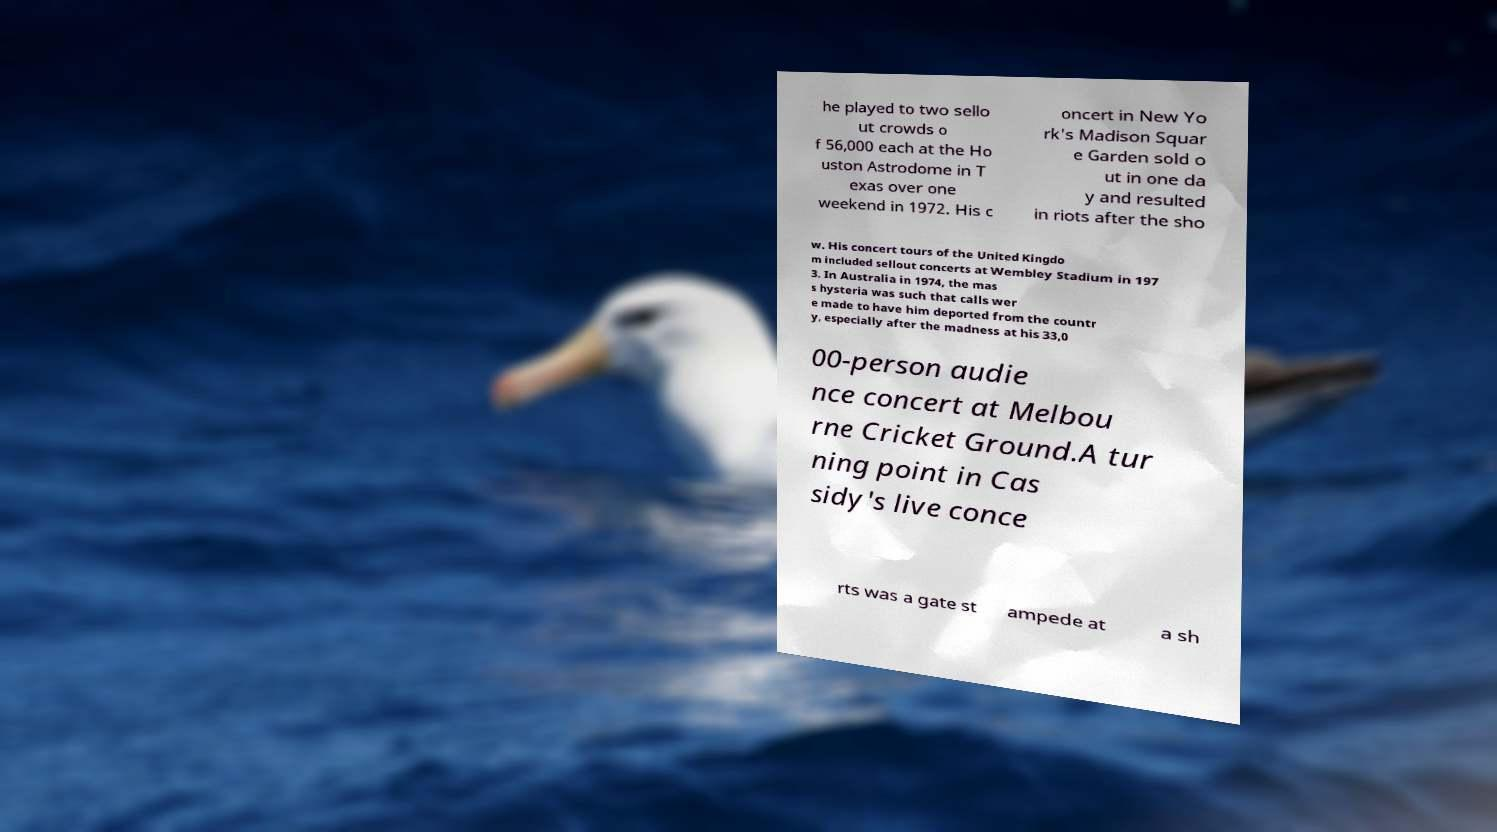Can you accurately transcribe the text from the provided image for me? he played to two sello ut crowds o f 56,000 each at the Ho uston Astrodome in T exas over one weekend in 1972. His c oncert in New Yo rk's Madison Squar e Garden sold o ut in one da y and resulted in riots after the sho w. His concert tours of the United Kingdo m included sellout concerts at Wembley Stadium in 197 3. In Australia in 1974, the mas s hysteria was such that calls wer e made to have him deported from the countr y, especially after the madness at his 33,0 00-person audie nce concert at Melbou rne Cricket Ground.A tur ning point in Cas sidy's live conce rts was a gate st ampede at a sh 